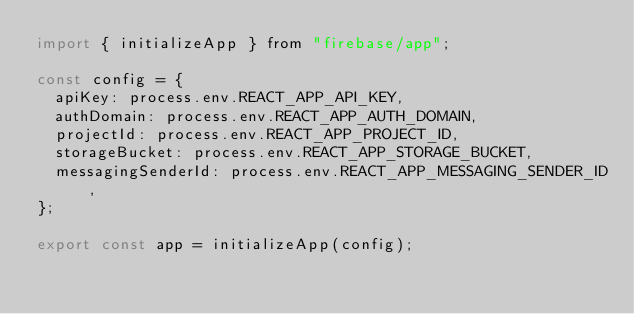<code> <loc_0><loc_0><loc_500><loc_500><_JavaScript_>import { initializeApp } from "firebase/app";

const config = {
  apiKey: process.env.REACT_APP_API_KEY,
  authDomain: process.env.REACT_APP_AUTH_DOMAIN,
  projectId: process.env.REACT_APP_PROJECT_ID,
  storageBucket: process.env.REACT_APP_STORAGE_BUCKET,
  messagingSenderId: process.env.REACT_APP_MESSAGING_SENDER_ID,
};

export const app = initializeApp(config);
</code> 